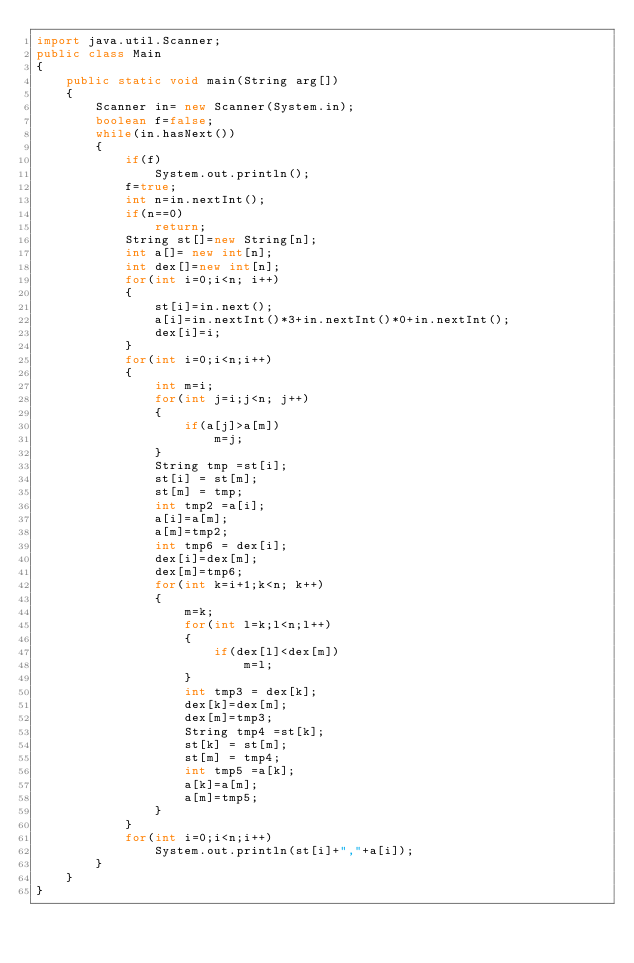<code> <loc_0><loc_0><loc_500><loc_500><_Java_>import java.util.Scanner;
public class Main
{
	public static void main(String arg[])
	{
		Scanner in= new Scanner(System.in);
		boolean f=false;
		while(in.hasNext())
		{
			if(f)
				System.out.println();
			f=true;
			int n=in.nextInt();
			if(n==0)
				return;
			String st[]=new String[n];
			int a[]= new int[n];
			int dex[]=new int[n];
			for(int i=0;i<n; i++)
			{
				st[i]=in.next();
				a[i]=in.nextInt()*3+in.nextInt()*0+in.nextInt();
				dex[i]=i;
			}
			for(int i=0;i<n;i++)
			{
				int m=i;
				for(int j=i;j<n; j++)
				{
					if(a[j]>a[m])
						m=j;
				}
				String tmp =st[i];
				st[i] = st[m];
				st[m] = tmp;
				int tmp2 =a[i];
				a[i]=a[m];
				a[m]=tmp2;
				int tmp6 = dex[i];
				dex[i]=dex[m];
				dex[m]=tmp6;
				for(int k=i+1;k<n; k++)
				{
					m=k;
					for(int l=k;l<n;l++)
					{
						if(dex[l]<dex[m])
							m=l;
					}
					int tmp3 = dex[k];
					dex[k]=dex[m];
					dex[m]=tmp3;
					String tmp4 =st[k];
					st[k] = st[m];
					st[m] = tmp4;
					int tmp5 =a[k];
					a[k]=a[m];
					a[m]=tmp5;
				}
			}
			for(int i=0;i<n;i++)
				System.out.println(st[i]+","+a[i]);
		}
	}
}</code> 